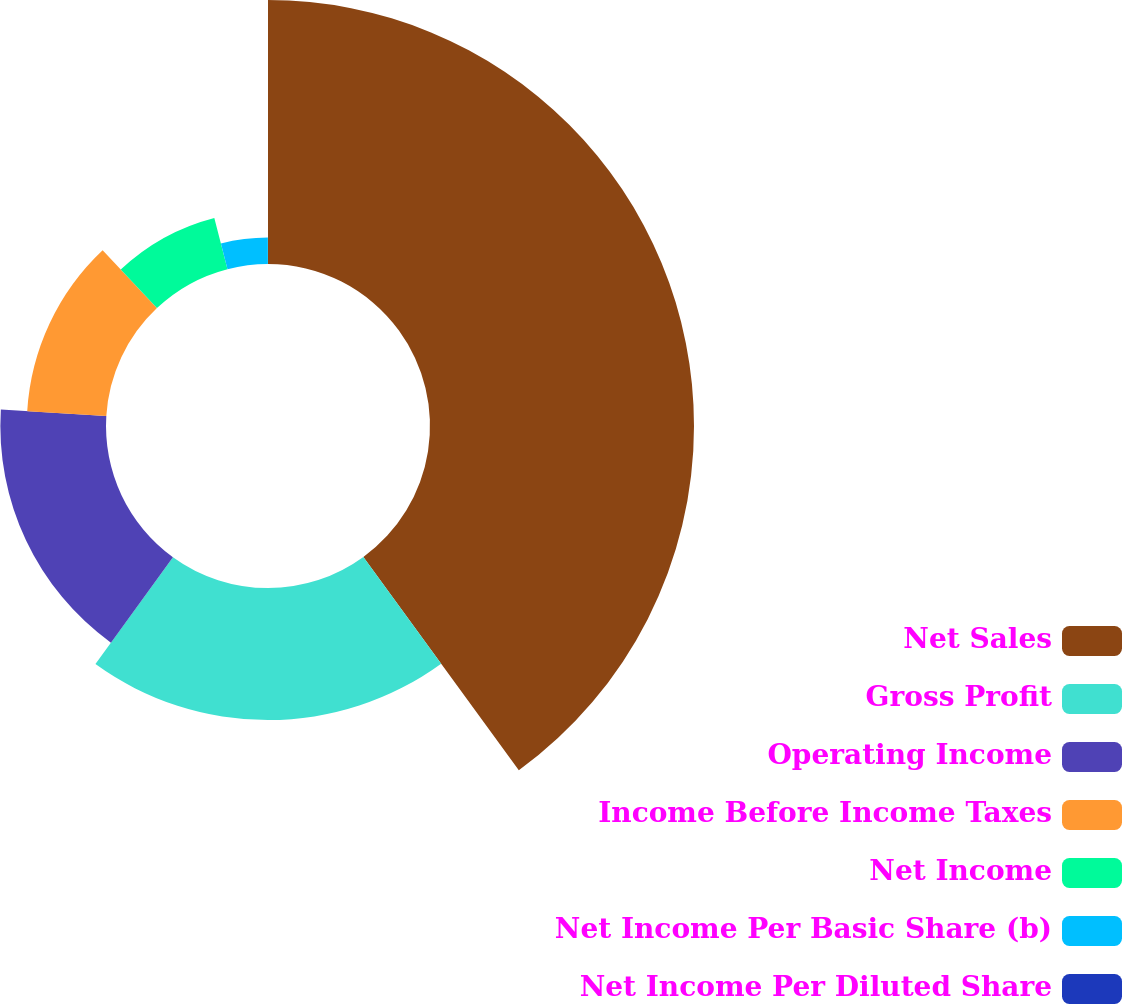Convert chart. <chart><loc_0><loc_0><loc_500><loc_500><pie_chart><fcel>Net Sales<fcel>Gross Profit<fcel>Operating Income<fcel>Income Before Income Taxes<fcel>Net Income<fcel>Net Income Per Basic Share (b)<fcel>Net Income Per Diluted Share<nl><fcel>39.98%<fcel>20.0%<fcel>16.0%<fcel>12.0%<fcel>8.0%<fcel>4.01%<fcel>0.01%<nl></chart> 